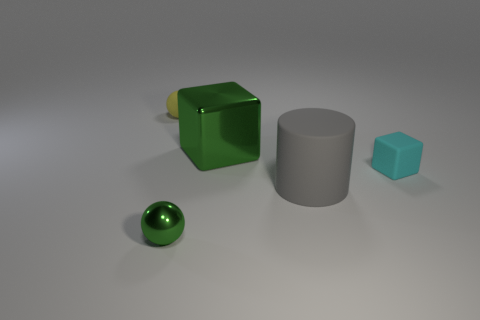Subtract all red blocks. Subtract all yellow cylinders. How many blocks are left? 2 Subtract all green blocks. How many red spheres are left? 0 Add 5 grays. How many objects exist? 0 Subtract all small metal spheres. Subtract all small spheres. How many objects are left? 2 Add 1 tiny cubes. How many tiny cubes are left? 2 Add 2 cyan cubes. How many cyan cubes exist? 3 Add 5 large things. How many objects exist? 10 Subtract all cyan cubes. How many cubes are left? 1 Subtract 0 purple cubes. How many objects are left? 5 Subtract all cylinders. How many objects are left? 4 